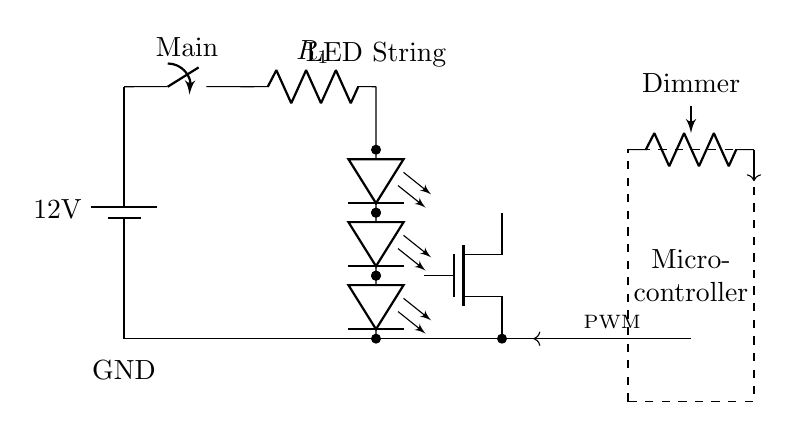What is the voltage of the power supply? The voltage is 12 volts, as indicated next to the battery symbol in the circuit diagram.
Answer: 12 volts What component limits the current to the LED string? The component that limits the current is the resistor labeled R1, which is connected directly in series before the LED string.
Answer: R1 What type of transistor is used for dimming? The transistor used for dimming is a N-channel MOSFET, indicated by the label adjacent to the MOSFET symbol in the diagram.
Answer: MOSFET How is the dimming function controlled in this circuit? The dimming function is controlled by the microcontroller using a PWM signal, which is sent to the gate of the MOSFET, allowing for modulation of the LED brightness.
Answer: PWM signal What is the function of the dimmer potentiometer in the circuit? The dimmer potentiometer serves to adjust the resistance, which affects the PWM signal generated by the microcontroller, thus allowing for variable brightness of the LEDs.
Answer: Adjustable brightness What happens when the main switch is turned off? When the main switch is turned off, the entire circuit is interrupted, and no current flows to the LEDs or the rest of the circuit, turning off the light completely.
Answer: Circuit off What is the arrangement of the LEDs in the circuit? The LEDs are arranged in series, as shown by the multiple LED symbols connected one after the other along the same path in the circuit.
Answer: Series arrangement 